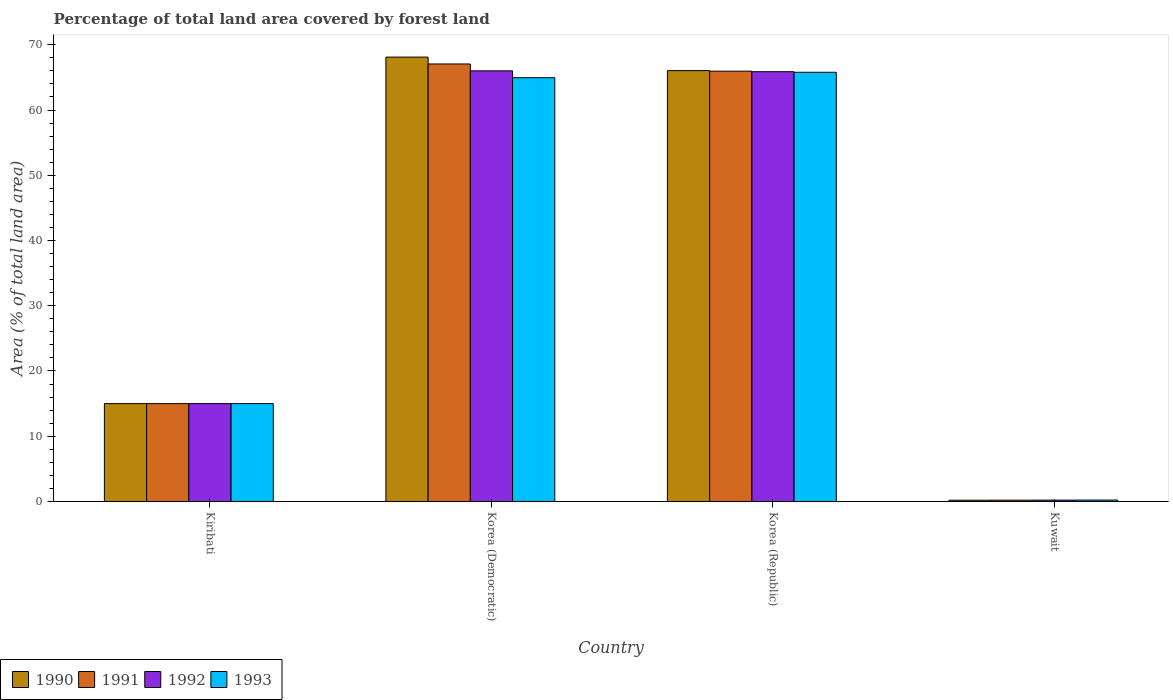Are the number of bars on each tick of the X-axis equal?
Offer a terse response. Yes. How many bars are there on the 3rd tick from the left?
Give a very brief answer. 4. What is the label of the 1st group of bars from the left?
Your answer should be compact. Kiribati. In how many cases, is the number of bars for a given country not equal to the number of legend labels?
Your answer should be very brief. 0. What is the percentage of forest land in 1991 in Kiribati?
Your answer should be compact. 15. Across all countries, what is the maximum percentage of forest land in 1991?
Provide a succinct answer. 67.06. Across all countries, what is the minimum percentage of forest land in 1993?
Your answer should be very brief. 0.22. In which country was the percentage of forest land in 1990 maximum?
Give a very brief answer. Korea (Democratic). In which country was the percentage of forest land in 1991 minimum?
Provide a short and direct response. Kuwait. What is the total percentage of forest land in 1993 in the graph?
Offer a terse response. 145.95. What is the difference between the percentage of forest land in 1990 in Kiribati and that in Kuwait?
Your answer should be compact. 14.81. What is the difference between the percentage of forest land in 1992 in Korea (Republic) and the percentage of forest land in 1991 in Kiribati?
Keep it short and to the point. 50.87. What is the average percentage of forest land in 1993 per country?
Offer a terse response. 36.49. What is the difference between the percentage of forest land of/in 1992 and percentage of forest land of/in 1993 in Kuwait?
Keep it short and to the point. -0.01. In how many countries, is the percentage of forest land in 1993 greater than 6 %?
Give a very brief answer. 3. What is the ratio of the percentage of forest land in 1993 in Kiribati to that in Korea (Democratic)?
Ensure brevity in your answer.  0.23. What is the difference between the highest and the second highest percentage of forest land in 1990?
Provide a succinct answer. -2.07. What is the difference between the highest and the lowest percentage of forest land in 1993?
Ensure brevity in your answer.  65.57. Is the sum of the percentage of forest land in 1993 in Kiribati and Kuwait greater than the maximum percentage of forest land in 1991 across all countries?
Keep it short and to the point. No. Is it the case that in every country, the sum of the percentage of forest land in 1992 and percentage of forest land in 1993 is greater than the sum of percentage of forest land in 1991 and percentage of forest land in 1990?
Your answer should be compact. No. What does the 2nd bar from the right in Korea (Democratic) represents?
Your response must be concise. 1992. Is it the case that in every country, the sum of the percentage of forest land in 1990 and percentage of forest land in 1992 is greater than the percentage of forest land in 1993?
Provide a short and direct response. Yes. What is the difference between two consecutive major ticks on the Y-axis?
Provide a short and direct response. 10. Does the graph contain grids?
Your answer should be very brief. No. How are the legend labels stacked?
Make the answer very short. Horizontal. What is the title of the graph?
Provide a short and direct response. Percentage of total land area covered by forest land. Does "1992" appear as one of the legend labels in the graph?
Make the answer very short. Yes. What is the label or title of the Y-axis?
Make the answer very short. Area (% of total land area). What is the Area (% of total land area) in 1991 in Kiribati?
Make the answer very short. 15. What is the Area (% of total land area) of 1992 in Kiribati?
Make the answer very short. 15. What is the Area (% of total land area) of 1993 in Kiribati?
Provide a short and direct response. 15. What is the Area (% of total land area) of 1990 in Korea (Democratic)?
Offer a very short reply. 68.11. What is the Area (% of total land area) of 1991 in Korea (Democratic)?
Offer a terse response. 67.06. What is the Area (% of total land area) of 1992 in Korea (Democratic)?
Your response must be concise. 66. What is the Area (% of total land area) in 1993 in Korea (Democratic)?
Keep it short and to the point. 64.95. What is the Area (% of total land area) of 1990 in Korea (Republic)?
Keep it short and to the point. 66.04. What is the Area (% of total land area) of 1991 in Korea (Republic)?
Provide a succinct answer. 65.95. What is the Area (% of total land area) of 1992 in Korea (Republic)?
Your answer should be very brief. 65.87. What is the Area (% of total land area) of 1993 in Korea (Republic)?
Your answer should be compact. 65.78. What is the Area (% of total land area) in 1990 in Kuwait?
Ensure brevity in your answer.  0.19. What is the Area (% of total land area) in 1991 in Kuwait?
Your answer should be very brief. 0.2. What is the Area (% of total land area) in 1992 in Kuwait?
Make the answer very short. 0.21. What is the Area (% of total land area) of 1993 in Kuwait?
Give a very brief answer. 0.22. Across all countries, what is the maximum Area (% of total land area) in 1990?
Offer a very short reply. 68.11. Across all countries, what is the maximum Area (% of total land area) of 1991?
Your answer should be very brief. 67.06. Across all countries, what is the maximum Area (% of total land area) of 1992?
Give a very brief answer. 66. Across all countries, what is the maximum Area (% of total land area) in 1993?
Give a very brief answer. 65.78. Across all countries, what is the minimum Area (% of total land area) in 1990?
Provide a short and direct response. 0.19. Across all countries, what is the minimum Area (% of total land area) of 1991?
Ensure brevity in your answer.  0.2. Across all countries, what is the minimum Area (% of total land area) in 1992?
Give a very brief answer. 0.21. Across all countries, what is the minimum Area (% of total land area) in 1993?
Keep it short and to the point. 0.22. What is the total Area (% of total land area) of 1990 in the graph?
Ensure brevity in your answer.  149.34. What is the total Area (% of total land area) of 1991 in the graph?
Keep it short and to the point. 148.21. What is the total Area (% of total land area) of 1992 in the graph?
Your response must be concise. 147.08. What is the total Area (% of total land area) in 1993 in the graph?
Ensure brevity in your answer.  145.95. What is the difference between the Area (% of total land area) of 1990 in Kiribati and that in Korea (Democratic)?
Provide a succinct answer. -53.11. What is the difference between the Area (% of total land area) in 1991 in Kiribati and that in Korea (Democratic)?
Your response must be concise. -52.06. What is the difference between the Area (% of total land area) in 1992 in Kiribati and that in Korea (Democratic)?
Offer a terse response. -51. What is the difference between the Area (% of total land area) of 1993 in Kiribati and that in Korea (Democratic)?
Provide a succinct answer. -49.95. What is the difference between the Area (% of total land area) of 1990 in Kiribati and that in Korea (Republic)?
Give a very brief answer. -51.04. What is the difference between the Area (% of total land area) in 1991 in Kiribati and that in Korea (Republic)?
Your answer should be very brief. -50.95. What is the difference between the Area (% of total land area) of 1992 in Kiribati and that in Korea (Republic)?
Your response must be concise. -50.87. What is the difference between the Area (% of total land area) in 1993 in Kiribati and that in Korea (Republic)?
Your answer should be very brief. -50.78. What is the difference between the Area (% of total land area) of 1990 in Kiribati and that in Kuwait?
Offer a very short reply. 14.81. What is the difference between the Area (% of total land area) of 1991 in Kiribati and that in Kuwait?
Keep it short and to the point. 14.8. What is the difference between the Area (% of total land area) of 1992 in Kiribati and that in Kuwait?
Provide a succinct answer. 14.79. What is the difference between the Area (% of total land area) of 1993 in Kiribati and that in Kuwait?
Ensure brevity in your answer.  14.78. What is the difference between the Area (% of total land area) of 1990 in Korea (Democratic) and that in Korea (Republic)?
Provide a short and direct response. 2.07. What is the difference between the Area (% of total land area) in 1991 in Korea (Democratic) and that in Korea (Republic)?
Offer a terse response. 1.1. What is the difference between the Area (% of total land area) in 1992 in Korea (Democratic) and that in Korea (Republic)?
Offer a very short reply. 0.14. What is the difference between the Area (% of total land area) of 1993 in Korea (Democratic) and that in Korea (Republic)?
Offer a very short reply. -0.83. What is the difference between the Area (% of total land area) in 1990 in Korea (Democratic) and that in Kuwait?
Your answer should be very brief. 67.92. What is the difference between the Area (% of total land area) of 1991 in Korea (Democratic) and that in Kuwait?
Your response must be concise. 66.85. What is the difference between the Area (% of total land area) of 1992 in Korea (Democratic) and that in Kuwait?
Offer a terse response. 65.79. What is the difference between the Area (% of total land area) of 1993 in Korea (Democratic) and that in Kuwait?
Offer a terse response. 64.73. What is the difference between the Area (% of total land area) in 1990 in Korea (Republic) and that in Kuwait?
Your answer should be very brief. 65.84. What is the difference between the Area (% of total land area) of 1991 in Korea (Republic) and that in Kuwait?
Offer a terse response. 65.75. What is the difference between the Area (% of total land area) in 1992 in Korea (Republic) and that in Kuwait?
Your answer should be very brief. 65.66. What is the difference between the Area (% of total land area) of 1993 in Korea (Republic) and that in Kuwait?
Offer a terse response. 65.57. What is the difference between the Area (% of total land area) of 1990 in Kiribati and the Area (% of total land area) of 1991 in Korea (Democratic)?
Ensure brevity in your answer.  -52.06. What is the difference between the Area (% of total land area) of 1990 in Kiribati and the Area (% of total land area) of 1992 in Korea (Democratic)?
Your response must be concise. -51. What is the difference between the Area (% of total land area) in 1990 in Kiribati and the Area (% of total land area) in 1993 in Korea (Democratic)?
Your answer should be compact. -49.95. What is the difference between the Area (% of total land area) of 1991 in Kiribati and the Area (% of total land area) of 1992 in Korea (Democratic)?
Ensure brevity in your answer.  -51. What is the difference between the Area (% of total land area) of 1991 in Kiribati and the Area (% of total land area) of 1993 in Korea (Democratic)?
Provide a short and direct response. -49.95. What is the difference between the Area (% of total land area) of 1992 in Kiribati and the Area (% of total land area) of 1993 in Korea (Democratic)?
Provide a short and direct response. -49.95. What is the difference between the Area (% of total land area) in 1990 in Kiribati and the Area (% of total land area) in 1991 in Korea (Republic)?
Provide a short and direct response. -50.95. What is the difference between the Area (% of total land area) in 1990 in Kiribati and the Area (% of total land area) in 1992 in Korea (Republic)?
Your answer should be very brief. -50.87. What is the difference between the Area (% of total land area) of 1990 in Kiribati and the Area (% of total land area) of 1993 in Korea (Republic)?
Provide a short and direct response. -50.78. What is the difference between the Area (% of total land area) in 1991 in Kiribati and the Area (% of total land area) in 1992 in Korea (Republic)?
Your answer should be compact. -50.87. What is the difference between the Area (% of total land area) of 1991 in Kiribati and the Area (% of total land area) of 1993 in Korea (Republic)?
Ensure brevity in your answer.  -50.78. What is the difference between the Area (% of total land area) in 1992 in Kiribati and the Area (% of total land area) in 1993 in Korea (Republic)?
Offer a terse response. -50.78. What is the difference between the Area (% of total land area) in 1990 in Kiribati and the Area (% of total land area) in 1991 in Kuwait?
Provide a short and direct response. 14.8. What is the difference between the Area (% of total land area) in 1990 in Kiribati and the Area (% of total land area) in 1992 in Kuwait?
Provide a short and direct response. 14.79. What is the difference between the Area (% of total land area) of 1990 in Kiribati and the Area (% of total land area) of 1993 in Kuwait?
Your answer should be very brief. 14.78. What is the difference between the Area (% of total land area) in 1991 in Kiribati and the Area (% of total land area) in 1992 in Kuwait?
Ensure brevity in your answer.  14.79. What is the difference between the Area (% of total land area) of 1991 in Kiribati and the Area (% of total land area) of 1993 in Kuwait?
Ensure brevity in your answer.  14.78. What is the difference between the Area (% of total land area) of 1992 in Kiribati and the Area (% of total land area) of 1993 in Kuwait?
Provide a succinct answer. 14.78. What is the difference between the Area (% of total land area) of 1990 in Korea (Democratic) and the Area (% of total land area) of 1991 in Korea (Republic)?
Your answer should be compact. 2.16. What is the difference between the Area (% of total land area) in 1990 in Korea (Democratic) and the Area (% of total land area) in 1992 in Korea (Republic)?
Offer a very short reply. 2.24. What is the difference between the Area (% of total land area) of 1990 in Korea (Democratic) and the Area (% of total land area) of 1993 in Korea (Republic)?
Offer a very short reply. 2.33. What is the difference between the Area (% of total land area) in 1991 in Korea (Democratic) and the Area (% of total land area) in 1992 in Korea (Republic)?
Keep it short and to the point. 1.19. What is the difference between the Area (% of total land area) of 1991 in Korea (Democratic) and the Area (% of total land area) of 1993 in Korea (Republic)?
Your answer should be very brief. 1.27. What is the difference between the Area (% of total land area) in 1992 in Korea (Democratic) and the Area (% of total land area) in 1993 in Korea (Republic)?
Ensure brevity in your answer.  0.22. What is the difference between the Area (% of total land area) in 1990 in Korea (Democratic) and the Area (% of total land area) in 1991 in Kuwait?
Your answer should be very brief. 67.91. What is the difference between the Area (% of total land area) of 1990 in Korea (Democratic) and the Area (% of total land area) of 1992 in Kuwait?
Offer a very short reply. 67.9. What is the difference between the Area (% of total land area) of 1990 in Korea (Democratic) and the Area (% of total land area) of 1993 in Kuwait?
Offer a very short reply. 67.89. What is the difference between the Area (% of total land area) of 1991 in Korea (Democratic) and the Area (% of total land area) of 1992 in Kuwait?
Your answer should be very brief. 66.85. What is the difference between the Area (% of total land area) in 1991 in Korea (Democratic) and the Area (% of total land area) in 1993 in Kuwait?
Provide a short and direct response. 66.84. What is the difference between the Area (% of total land area) of 1992 in Korea (Democratic) and the Area (% of total land area) of 1993 in Kuwait?
Your response must be concise. 65.79. What is the difference between the Area (% of total land area) in 1990 in Korea (Republic) and the Area (% of total land area) in 1991 in Kuwait?
Your answer should be very brief. 65.84. What is the difference between the Area (% of total land area) in 1990 in Korea (Republic) and the Area (% of total land area) in 1992 in Kuwait?
Ensure brevity in your answer.  65.83. What is the difference between the Area (% of total land area) of 1990 in Korea (Republic) and the Area (% of total land area) of 1993 in Kuwait?
Ensure brevity in your answer.  65.82. What is the difference between the Area (% of total land area) of 1991 in Korea (Republic) and the Area (% of total land area) of 1992 in Kuwait?
Provide a short and direct response. 65.74. What is the difference between the Area (% of total land area) in 1991 in Korea (Republic) and the Area (% of total land area) in 1993 in Kuwait?
Provide a succinct answer. 65.74. What is the difference between the Area (% of total land area) of 1992 in Korea (Republic) and the Area (% of total land area) of 1993 in Kuwait?
Make the answer very short. 65.65. What is the average Area (% of total land area) in 1990 per country?
Your answer should be compact. 37.34. What is the average Area (% of total land area) of 1991 per country?
Provide a short and direct response. 37.05. What is the average Area (% of total land area) of 1992 per country?
Offer a very short reply. 36.77. What is the average Area (% of total land area) of 1993 per country?
Your answer should be very brief. 36.49. What is the difference between the Area (% of total land area) of 1990 and Area (% of total land area) of 1992 in Kiribati?
Offer a very short reply. 0. What is the difference between the Area (% of total land area) of 1991 and Area (% of total land area) of 1992 in Kiribati?
Provide a succinct answer. 0. What is the difference between the Area (% of total land area) in 1990 and Area (% of total land area) in 1991 in Korea (Democratic)?
Offer a very short reply. 1.05. What is the difference between the Area (% of total land area) in 1990 and Area (% of total land area) in 1992 in Korea (Democratic)?
Your answer should be very brief. 2.11. What is the difference between the Area (% of total land area) of 1990 and Area (% of total land area) of 1993 in Korea (Democratic)?
Ensure brevity in your answer.  3.16. What is the difference between the Area (% of total land area) in 1991 and Area (% of total land area) in 1992 in Korea (Democratic)?
Keep it short and to the point. 1.05. What is the difference between the Area (% of total land area) of 1991 and Area (% of total land area) of 1993 in Korea (Democratic)?
Offer a terse response. 2.11. What is the difference between the Area (% of total land area) of 1992 and Area (% of total land area) of 1993 in Korea (Democratic)?
Your response must be concise. 1.05. What is the difference between the Area (% of total land area) of 1990 and Area (% of total land area) of 1991 in Korea (Republic)?
Make the answer very short. 0.09. What is the difference between the Area (% of total land area) in 1990 and Area (% of total land area) in 1992 in Korea (Republic)?
Offer a very short reply. 0.17. What is the difference between the Area (% of total land area) in 1990 and Area (% of total land area) in 1993 in Korea (Republic)?
Make the answer very short. 0.26. What is the difference between the Area (% of total land area) of 1991 and Area (% of total land area) of 1992 in Korea (Republic)?
Make the answer very short. 0.09. What is the difference between the Area (% of total land area) of 1991 and Area (% of total land area) of 1993 in Korea (Republic)?
Ensure brevity in your answer.  0.17. What is the difference between the Area (% of total land area) in 1992 and Area (% of total land area) in 1993 in Korea (Republic)?
Ensure brevity in your answer.  0.09. What is the difference between the Area (% of total land area) in 1990 and Area (% of total land area) in 1991 in Kuwait?
Keep it short and to the point. -0.01. What is the difference between the Area (% of total land area) of 1990 and Area (% of total land area) of 1992 in Kuwait?
Keep it short and to the point. -0.02. What is the difference between the Area (% of total land area) of 1990 and Area (% of total land area) of 1993 in Kuwait?
Offer a terse response. -0.02. What is the difference between the Area (% of total land area) of 1991 and Area (% of total land area) of 1992 in Kuwait?
Give a very brief answer. -0.01. What is the difference between the Area (% of total land area) of 1991 and Area (% of total land area) of 1993 in Kuwait?
Your answer should be very brief. -0.02. What is the difference between the Area (% of total land area) of 1992 and Area (% of total land area) of 1993 in Kuwait?
Your answer should be very brief. -0.01. What is the ratio of the Area (% of total land area) in 1990 in Kiribati to that in Korea (Democratic)?
Your answer should be compact. 0.22. What is the ratio of the Area (% of total land area) of 1991 in Kiribati to that in Korea (Democratic)?
Your response must be concise. 0.22. What is the ratio of the Area (% of total land area) of 1992 in Kiribati to that in Korea (Democratic)?
Your response must be concise. 0.23. What is the ratio of the Area (% of total land area) in 1993 in Kiribati to that in Korea (Democratic)?
Provide a succinct answer. 0.23. What is the ratio of the Area (% of total land area) in 1990 in Kiribati to that in Korea (Republic)?
Offer a terse response. 0.23. What is the ratio of the Area (% of total land area) of 1991 in Kiribati to that in Korea (Republic)?
Make the answer very short. 0.23. What is the ratio of the Area (% of total land area) in 1992 in Kiribati to that in Korea (Republic)?
Offer a very short reply. 0.23. What is the ratio of the Area (% of total land area) in 1993 in Kiribati to that in Korea (Republic)?
Make the answer very short. 0.23. What is the ratio of the Area (% of total land area) in 1990 in Kiribati to that in Kuwait?
Keep it short and to the point. 77.48. What is the ratio of the Area (% of total land area) of 1991 in Kiribati to that in Kuwait?
Your response must be concise. 74.46. What is the ratio of the Area (% of total land area) in 1992 in Kiribati to that in Kuwait?
Offer a very short reply. 71.66. What is the ratio of the Area (% of total land area) in 1993 in Kiribati to that in Kuwait?
Offer a terse response. 69.07. What is the ratio of the Area (% of total land area) in 1990 in Korea (Democratic) to that in Korea (Republic)?
Keep it short and to the point. 1.03. What is the ratio of the Area (% of total land area) of 1991 in Korea (Democratic) to that in Korea (Republic)?
Your answer should be very brief. 1.02. What is the ratio of the Area (% of total land area) in 1992 in Korea (Democratic) to that in Korea (Republic)?
Provide a succinct answer. 1. What is the ratio of the Area (% of total land area) in 1993 in Korea (Democratic) to that in Korea (Republic)?
Offer a terse response. 0.99. What is the ratio of the Area (% of total land area) in 1990 in Korea (Democratic) to that in Kuwait?
Your answer should be very brief. 351.8. What is the ratio of the Area (% of total land area) of 1991 in Korea (Democratic) to that in Kuwait?
Your answer should be compact. 332.85. What is the ratio of the Area (% of total land area) in 1992 in Korea (Democratic) to that in Kuwait?
Offer a very short reply. 315.33. What is the ratio of the Area (% of total land area) in 1993 in Korea (Democratic) to that in Kuwait?
Provide a short and direct response. 299.07. What is the ratio of the Area (% of total land area) of 1990 in Korea (Republic) to that in Kuwait?
Offer a terse response. 341.1. What is the ratio of the Area (% of total land area) of 1991 in Korea (Republic) to that in Kuwait?
Make the answer very short. 327.38. What is the ratio of the Area (% of total land area) of 1992 in Korea (Republic) to that in Kuwait?
Your response must be concise. 314.68. What is the ratio of the Area (% of total land area) in 1993 in Korea (Republic) to that in Kuwait?
Your answer should be compact. 302.91. What is the difference between the highest and the second highest Area (% of total land area) in 1990?
Offer a terse response. 2.07. What is the difference between the highest and the second highest Area (% of total land area) in 1991?
Ensure brevity in your answer.  1.1. What is the difference between the highest and the second highest Area (% of total land area) in 1992?
Keep it short and to the point. 0.14. What is the difference between the highest and the second highest Area (% of total land area) in 1993?
Your response must be concise. 0.83. What is the difference between the highest and the lowest Area (% of total land area) of 1990?
Your answer should be compact. 67.92. What is the difference between the highest and the lowest Area (% of total land area) in 1991?
Offer a very short reply. 66.85. What is the difference between the highest and the lowest Area (% of total land area) in 1992?
Give a very brief answer. 65.79. What is the difference between the highest and the lowest Area (% of total land area) in 1993?
Your answer should be compact. 65.57. 